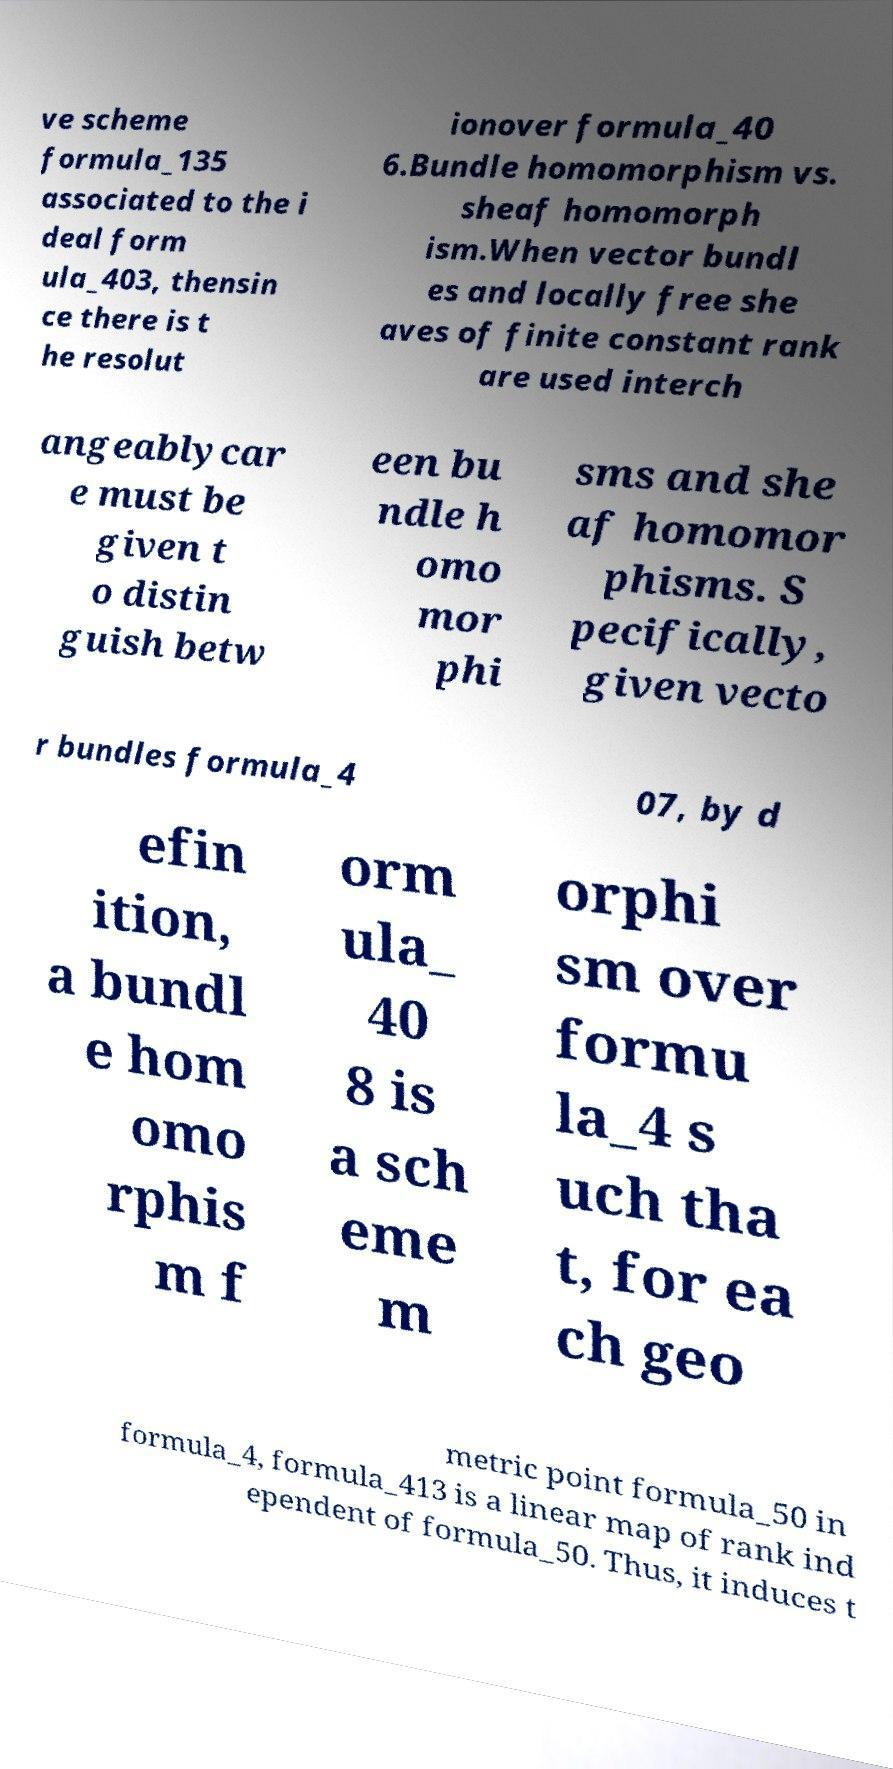There's text embedded in this image that I need extracted. Can you transcribe it verbatim? ve scheme formula_135 associated to the i deal form ula_403, thensin ce there is t he resolut ionover formula_40 6.Bundle homomorphism vs. sheaf homomorph ism.When vector bundl es and locally free she aves of finite constant rank are used interch angeablycar e must be given t o distin guish betw een bu ndle h omo mor phi sms and she af homomor phisms. S pecifically, given vecto r bundles formula_4 07, by d efin ition, a bundl e hom omo rphis m f orm ula_ 40 8 is a sch eme m orphi sm over formu la_4 s uch tha t, for ea ch geo metric point formula_50 in formula_4, formula_413 is a linear map of rank ind ependent of formula_50. Thus, it induces t 